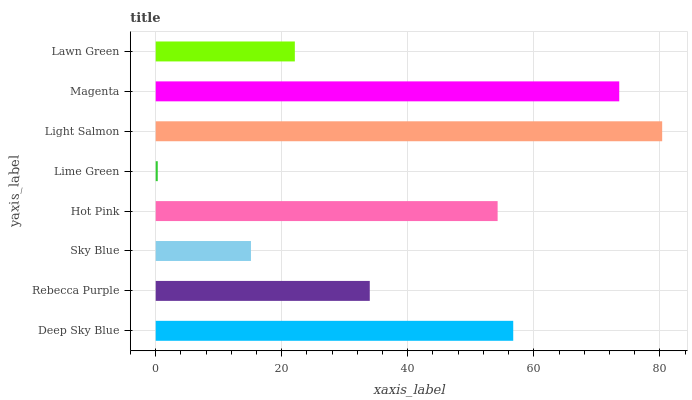Is Lime Green the minimum?
Answer yes or no. Yes. Is Light Salmon the maximum?
Answer yes or no. Yes. Is Rebecca Purple the minimum?
Answer yes or no. No. Is Rebecca Purple the maximum?
Answer yes or no. No. Is Deep Sky Blue greater than Rebecca Purple?
Answer yes or no. Yes. Is Rebecca Purple less than Deep Sky Blue?
Answer yes or no. Yes. Is Rebecca Purple greater than Deep Sky Blue?
Answer yes or no. No. Is Deep Sky Blue less than Rebecca Purple?
Answer yes or no. No. Is Hot Pink the high median?
Answer yes or no. Yes. Is Rebecca Purple the low median?
Answer yes or no. Yes. Is Rebecca Purple the high median?
Answer yes or no. No. Is Deep Sky Blue the low median?
Answer yes or no. No. 